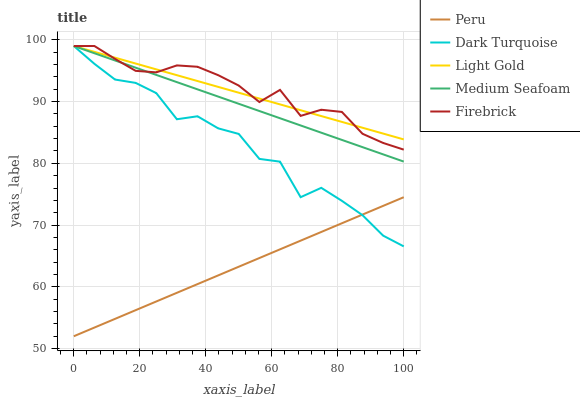Does Peru have the minimum area under the curve?
Answer yes or no. Yes. Does Firebrick have the maximum area under the curve?
Answer yes or no. Yes. Does Light Gold have the minimum area under the curve?
Answer yes or no. No. Does Light Gold have the maximum area under the curve?
Answer yes or no. No. Is Peru the smoothest?
Answer yes or no. Yes. Is Dark Turquoise the roughest?
Answer yes or no. Yes. Is Firebrick the smoothest?
Answer yes or no. No. Is Firebrick the roughest?
Answer yes or no. No. Does Firebrick have the lowest value?
Answer yes or no. No. Does Peru have the highest value?
Answer yes or no. No. Is Peru less than Firebrick?
Answer yes or no. Yes. Is Medium Seafoam greater than Peru?
Answer yes or no. Yes. Does Peru intersect Firebrick?
Answer yes or no. No. 